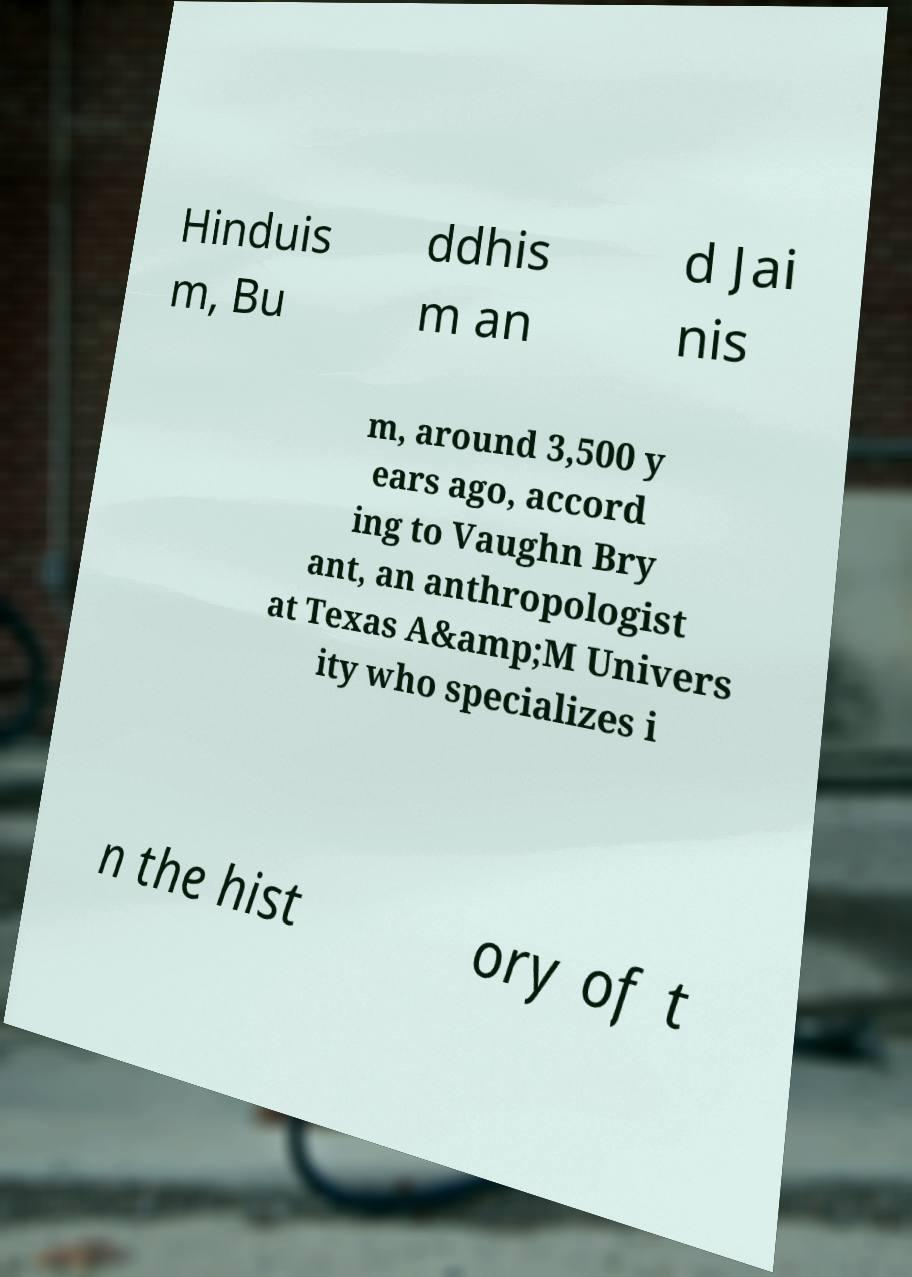For documentation purposes, I need the text within this image transcribed. Could you provide that? Hinduis m, Bu ddhis m an d Jai nis m, around 3,500 y ears ago, accord ing to Vaughn Bry ant, an anthropologist at Texas A&amp;M Univers ity who specializes i n the hist ory of t 